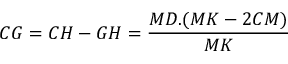<formula> <loc_0><loc_0><loc_500><loc_500>C G = C H - G H = { \frac { M D . ( M K - 2 C M ) } { M K } }</formula> 